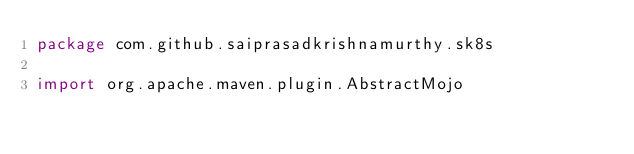Convert code to text. <code><loc_0><loc_0><loc_500><loc_500><_Kotlin_>package com.github.saiprasadkrishnamurthy.sk8s

import org.apache.maven.plugin.AbstractMojo</code> 